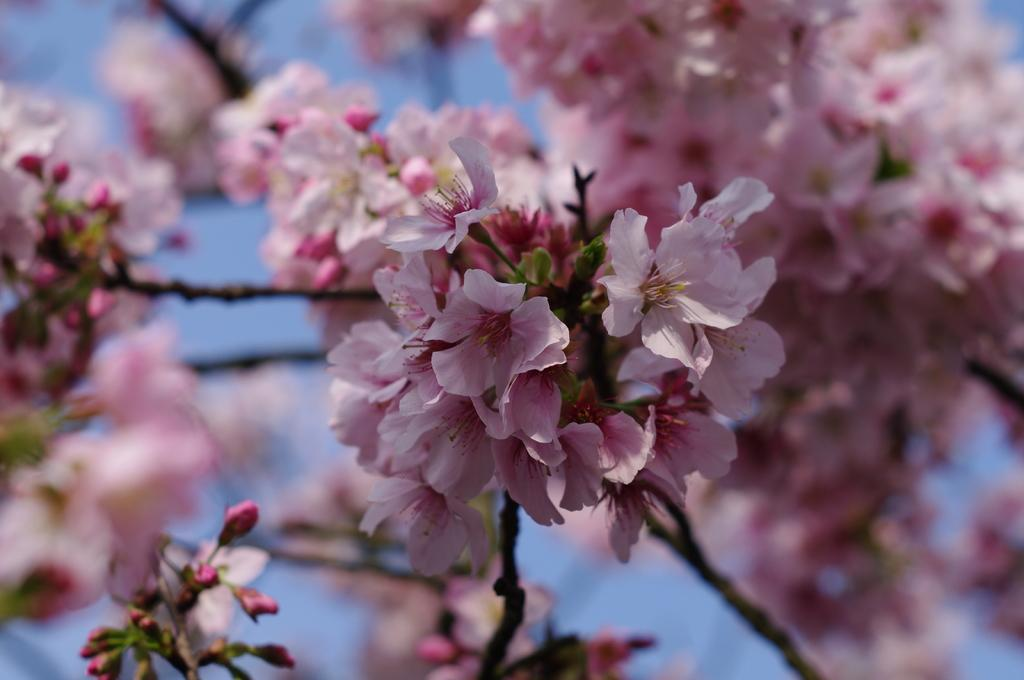What type of flora is present in the image? There are flowers in the image. What color are the flowers? The flowers are pink in color. What type of ship can be seen sailing in the scene depicted in the image? There is no ship or scene present in the image; it only features pink flowers. 